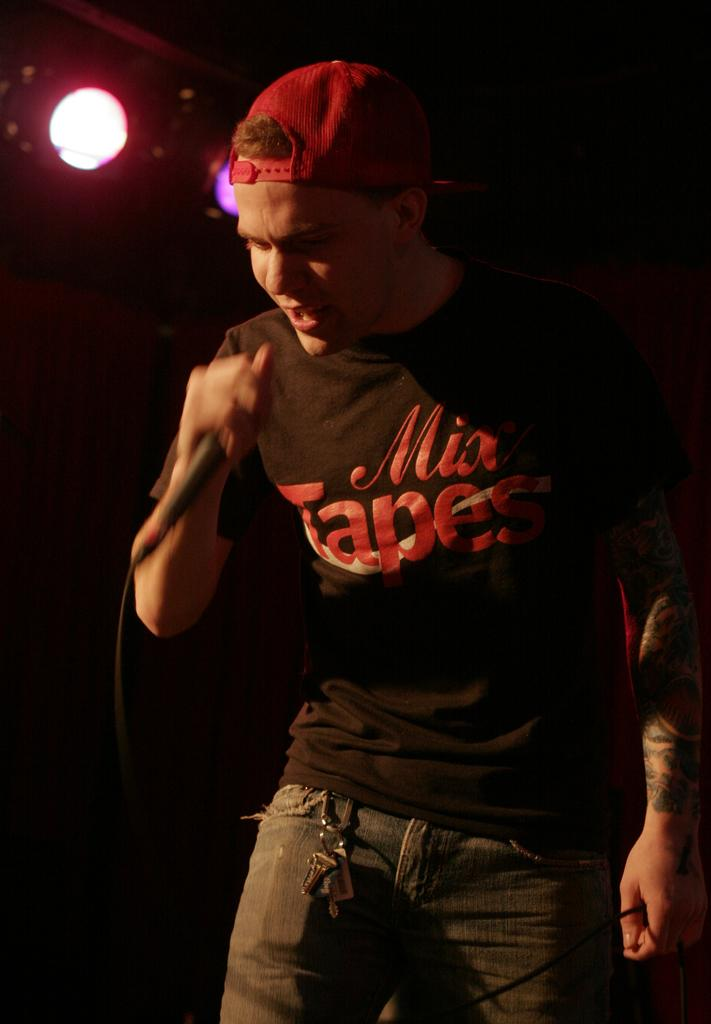Who is the main subject in the image? There is a man in the image. What is the man holding in the image? The man is holding a microphone. What is the man doing in the image? The man is singing. What can be seen in the background of the image? There are lights visible in the background of the image. Where is the nest located in the image? There is no nest present in the image. What type of coal is being used to fuel the man's performance in the image? There is no coal present in the image, and the man's performance is not fueled by coal. 